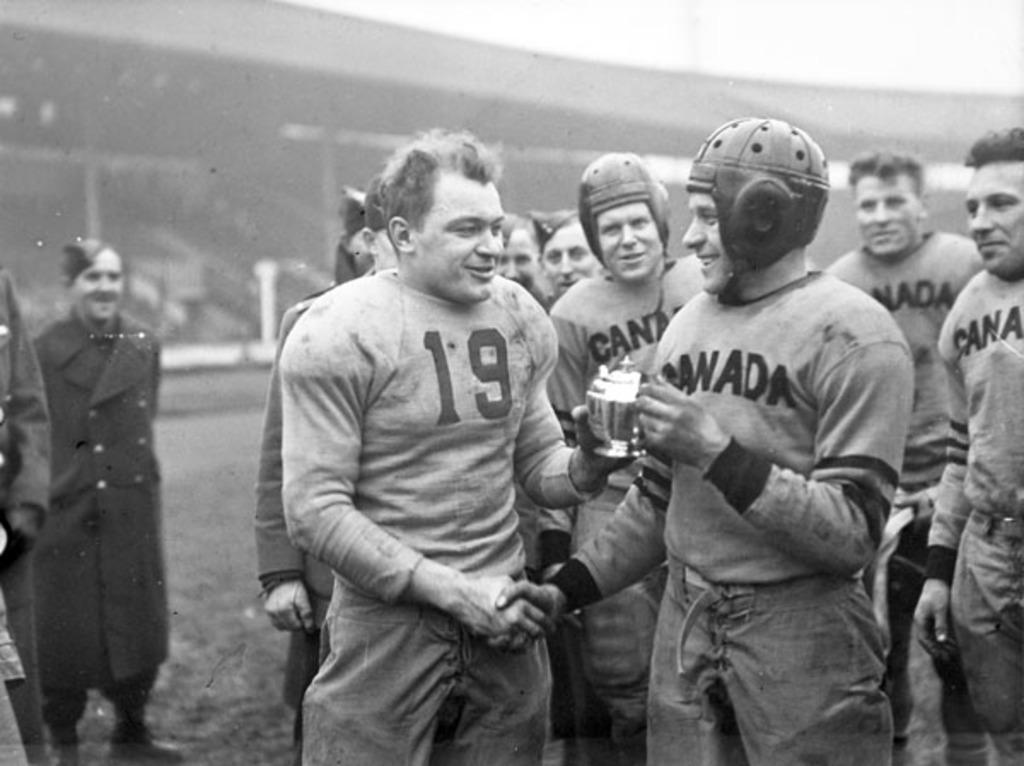What is the color scheme of the image? The image is black and white. What can be seen in the image? There are people standing in the image. What are some of the people wearing? Some of the people are wearing helmets. What is visible in the background of the image? There is a building visible in the background of the image. How many grapes are being held by the person in the image? There are no grapes present in the image. What type of hen can be seen in the image? There are no hens present in the image. 